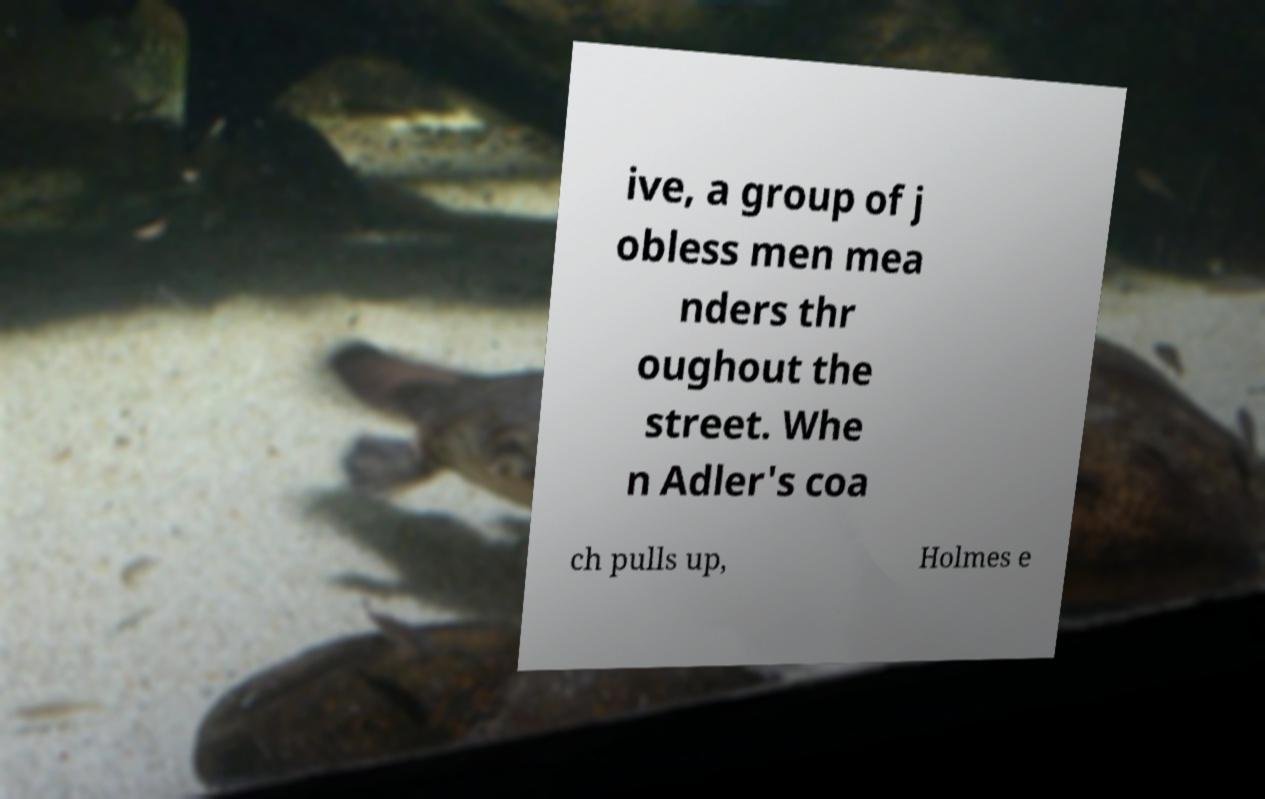What messages or text are displayed in this image? I need them in a readable, typed format. ive, a group of j obless men mea nders thr oughout the street. Whe n Adler's coa ch pulls up, Holmes e 